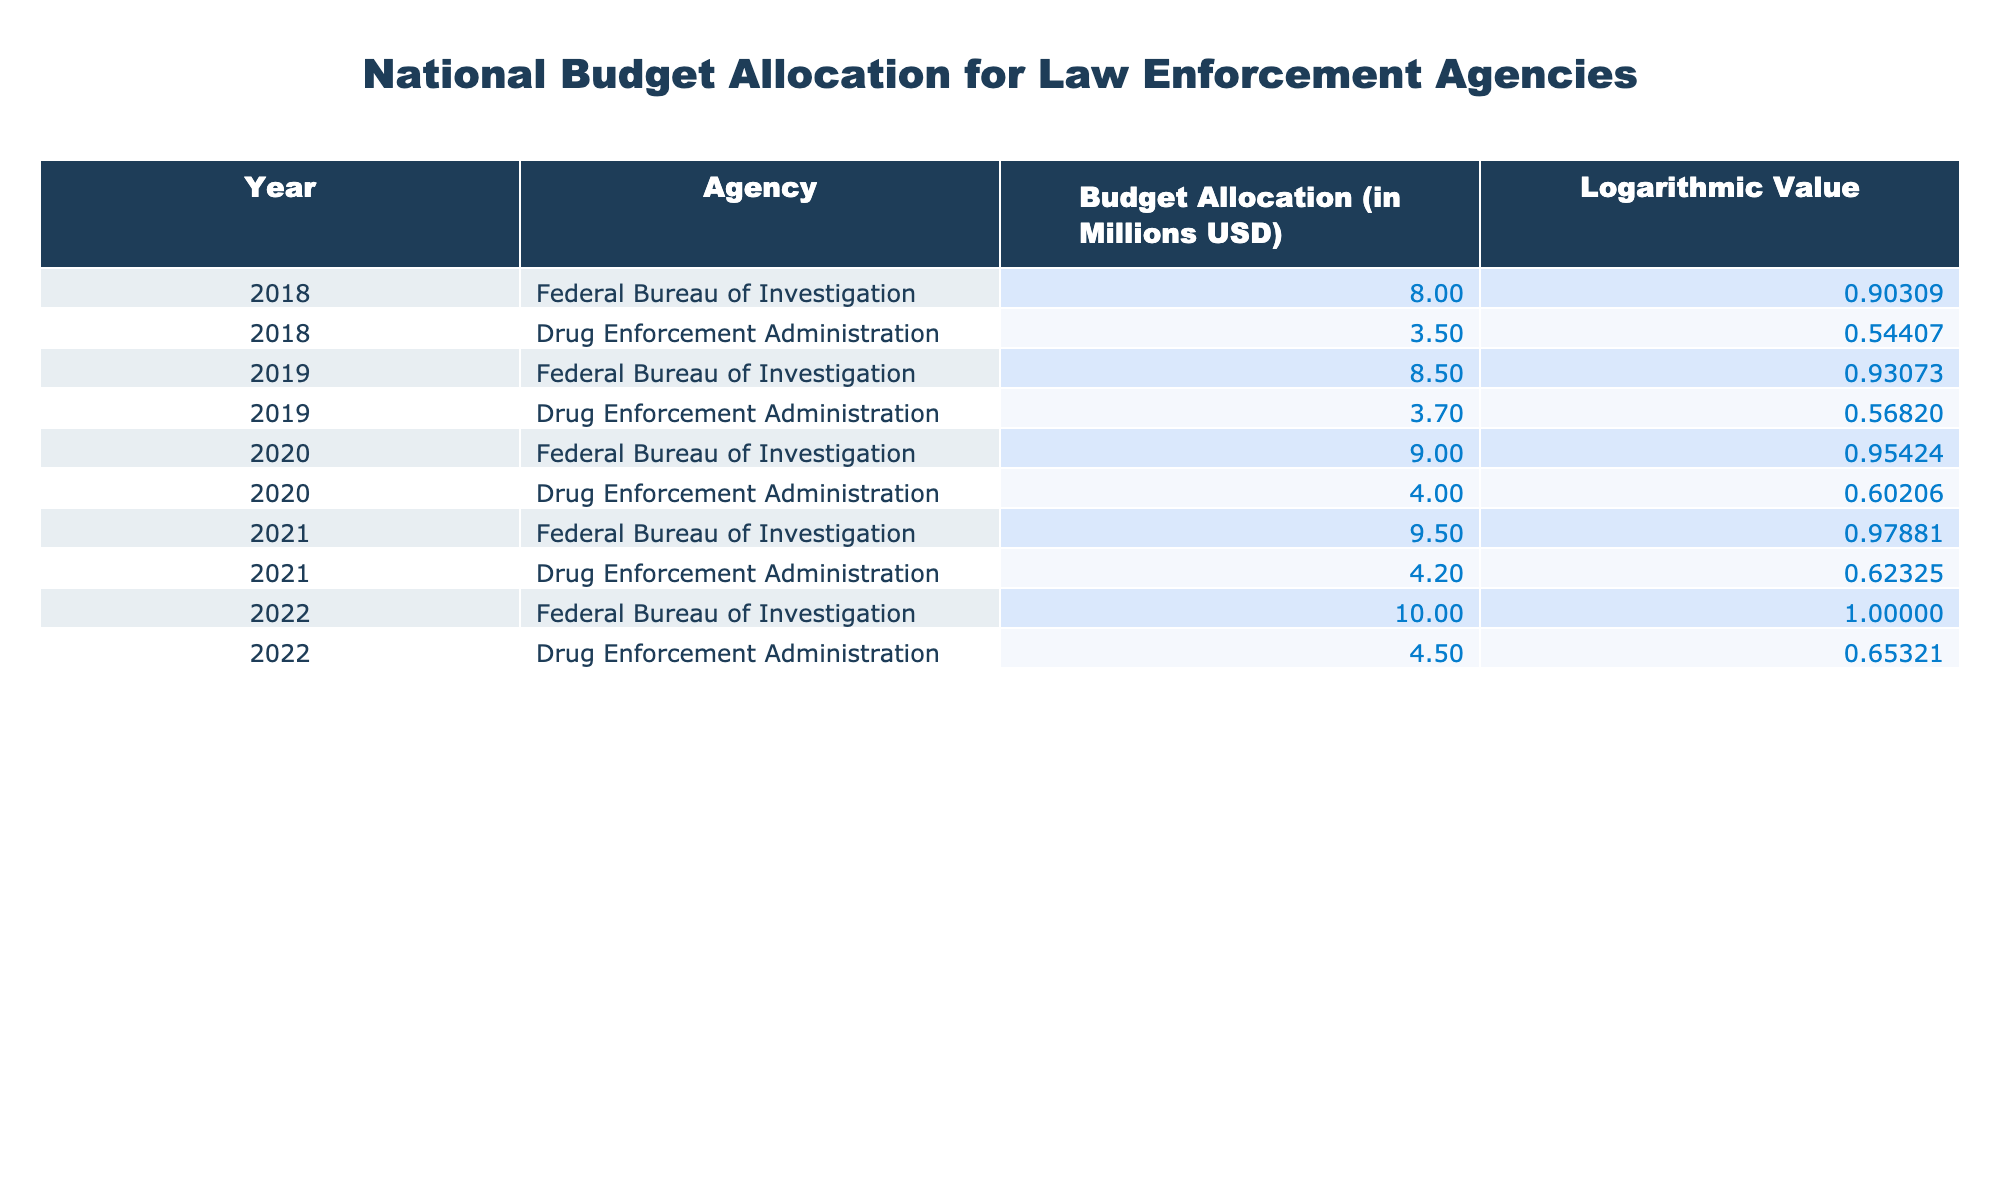What was the budget allocation for the Drug Enforcement Administration in 2021? The table shows the budget allocation for the Drug Enforcement Administration in 2021 as 4.2 million USD.
Answer: 4.2 million USD Which agency received the highest budget allocation in 2022? According to the table, the Federal Bureau of Investigation received the highest budget allocation in 2022 with 10 million USD.
Answer: Federal Bureau of Investigation What is the total budget allocation for the Federal Bureau of Investigation from 2018 to 2022? The budget allocations for the Federal Bureau of Investigation during this period are: 8, 8.5, 9, 9.5, and 10 million USD. Adding them up gives: 8 + 8.5 + 9 + 9.5 + 10 = 45 million USD.
Answer: 45 million USD Did the budget allocation for the Drug Enforcement Administration increase from 2018 to 2022? The budget allocations for the Drug Enforcement Administration from 2018 to 2022 are: 3.5, 3.7, 4, 4.2, and 4.5 million USD. Since these values are all increasing, the answer is yes.
Answer: Yes What was the percentage increase in the budget allocation for the Federal Bureau of Investigation from 2019 to 2020? The budget allocation for the Federal Bureau of Investigation increased from 8.5 million USD in 2019 to 9 million USD in 2020. The increase is (9 - 8.5) = 0.5 million USD. To find the percentage increase, the formula is: (0.5 / 8.5) * 100 = 5.88%.
Answer: 5.88% 